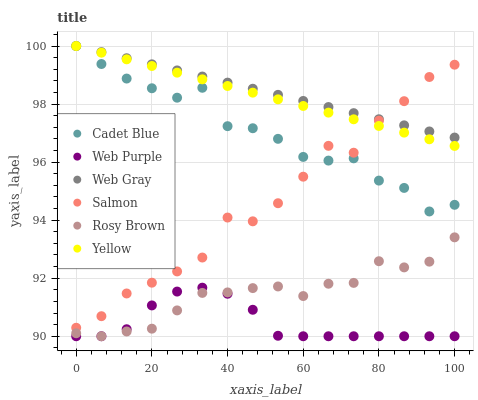Does Web Purple have the minimum area under the curve?
Answer yes or no. Yes. Does Web Gray have the maximum area under the curve?
Answer yes or no. Yes. Does Rosy Brown have the minimum area under the curve?
Answer yes or no. No. Does Rosy Brown have the maximum area under the curve?
Answer yes or no. No. Is Web Gray the smoothest?
Answer yes or no. Yes. Is Salmon the roughest?
Answer yes or no. Yes. Is Rosy Brown the smoothest?
Answer yes or no. No. Is Rosy Brown the roughest?
Answer yes or no. No. Does Rosy Brown have the lowest value?
Answer yes or no. Yes. Does Salmon have the lowest value?
Answer yes or no. No. Does Web Gray have the highest value?
Answer yes or no. Yes. Does Rosy Brown have the highest value?
Answer yes or no. No. Is Web Purple less than Salmon?
Answer yes or no. Yes. Is Cadet Blue greater than Rosy Brown?
Answer yes or no. Yes. Does Web Gray intersect Cadet Blue?
Answer yes or no. Yes. Is Web Gray less than Cadet Blue?
Answer yes or no. No. Is Web Gray greater than Cadet Blue?
Answer yes or no. No. Does Web Purple intersect Salmon?
Answer yes or no. No. 